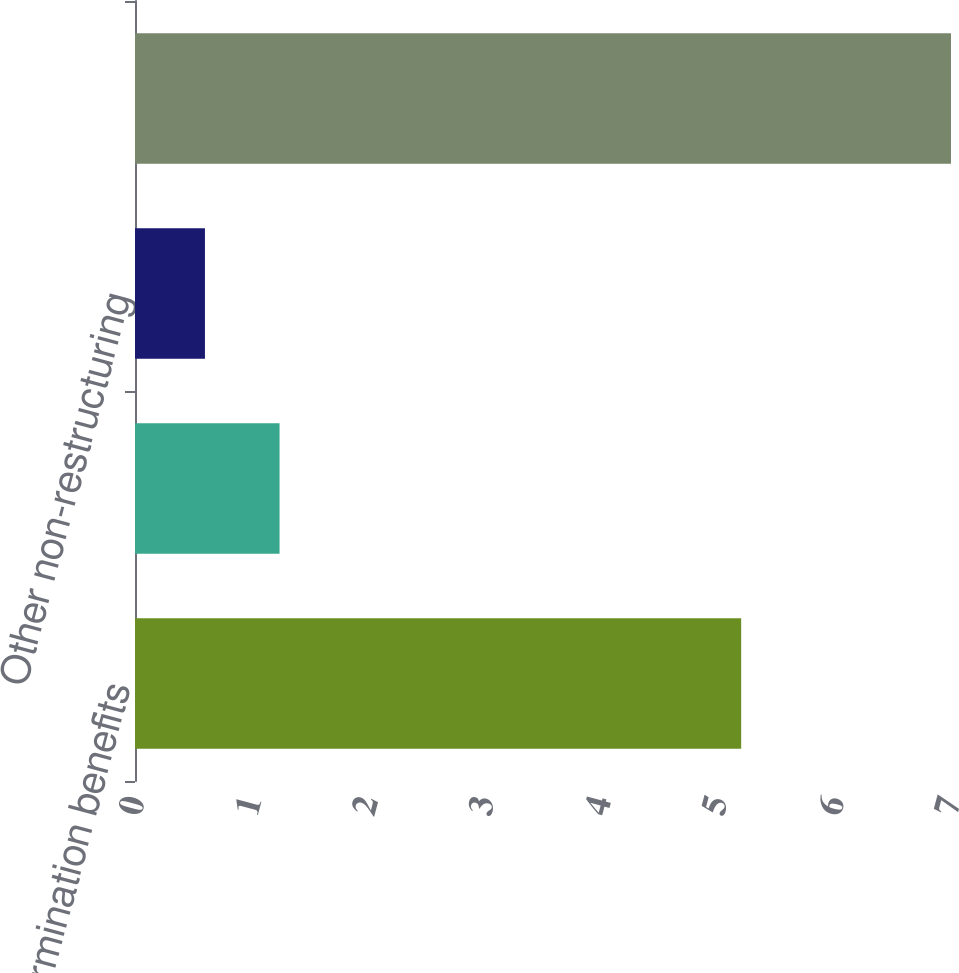Convert chart to OTSL. <chart><loc_0><loc_0><loc_500><loc_500><bar_chart><fcel>Costs for termination benefits<fcel>Other associated restructuring<fcel>Other non-restructuring<fcel>Total<nl><fcel>5.2<fcel>1.24<fcel>0.6<fcel>7<nl></chart> 